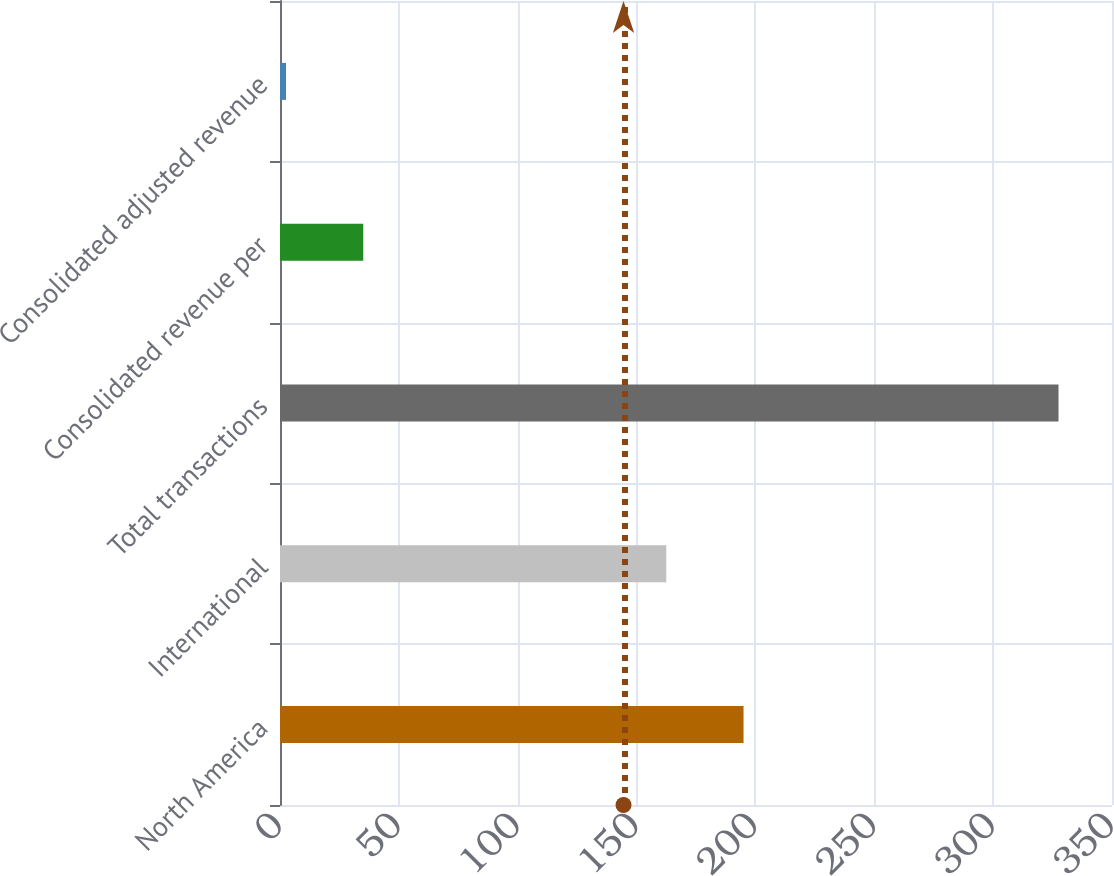Convert chart to OTSL. <chart><loc_0><loc_0><loc_500><loc_500><bar_chart><fcel>North America<fcel>International<fcel>Total transactions<fcel>Consolidated revenue per<fcel>Consolidated adjusted revenue<nl><fcel>195<fcel>162.5<fcel>327.5<fcel>35.03<fcel>2.53<nl></chart> 